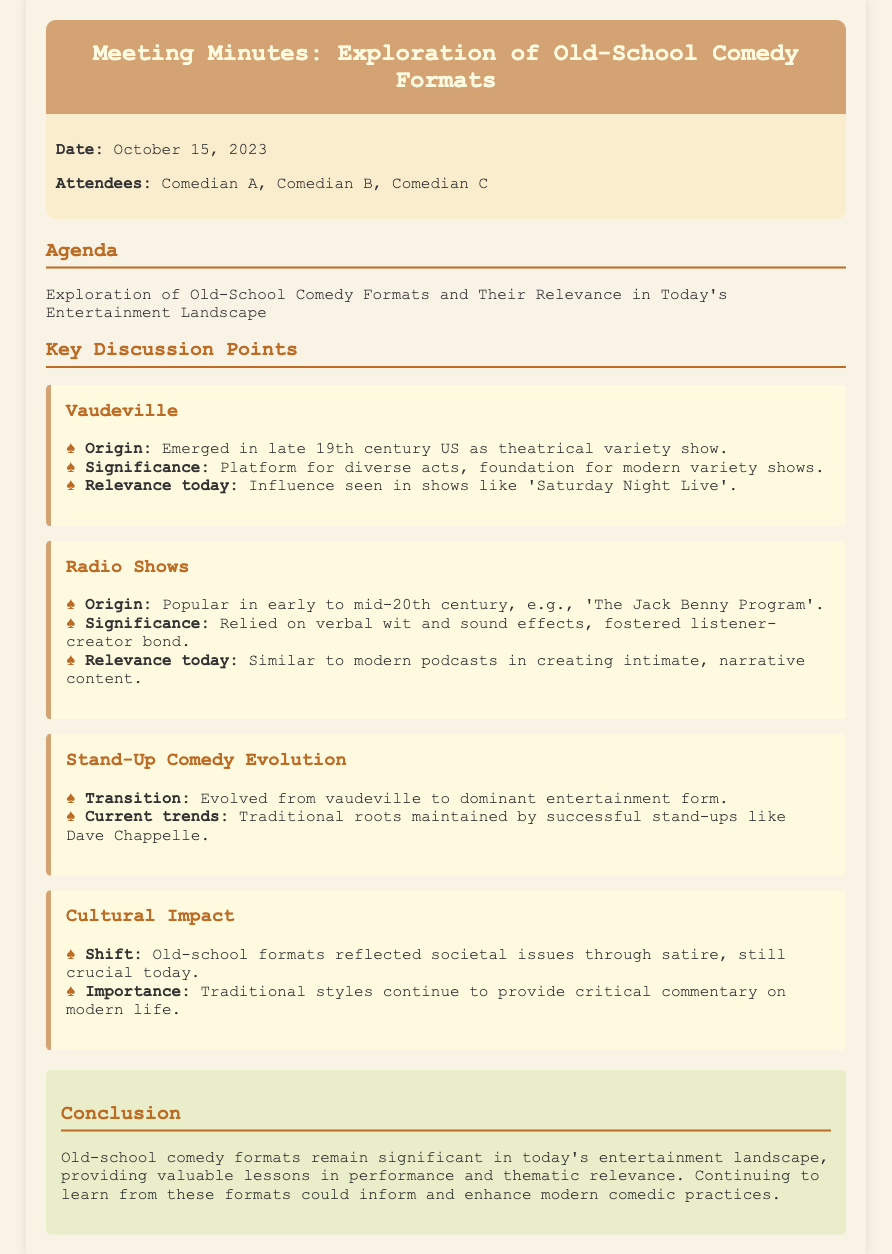what is the date of the meeting? The date of the meeting is mentioned in the date-attendees section of the document.
Answer: October 15, 2023 who attended the meeting? The attendees are listed in the date-attendees section of the document.
Answer: Comedian A, Comedian B, Comedian C what format is explored in the first topic? The first topic listed in the key discussion points focuses on a specific old-school comedy format.
Answer: Vaudeville what is the significance of radio shows mentioned in the document? The significance of radio shows is outlined in the description section for that topic.
Answer: Relied on verbal wit and sound effects, fostered listener-creator bond how did stand-up comedy evolve according to the document? The document describes the evolution of stand-up in relation to another comedy format.
Answer: Evolved from vaudeville what modern show is influenced by vaudeville? The document provides an example of a modern show that reflects the influence of vaudeville.
Answer: Saturday Night Live why are old-school formats still relevant today? The document explains why these formats maintain their importance in the current entertainment landscape.
Answer: Provide critical commentary on modern life how do old-school formats reflect societal issues? The document mentions the role of old-school formats in addressing societal themes.
Answer: Reflected societal issues through satire what type of content do modern podcasts create similar to radio shows? The document describes the relationship between modern content formats and old-school radio shows.
Answer: Intimate, narrative content 